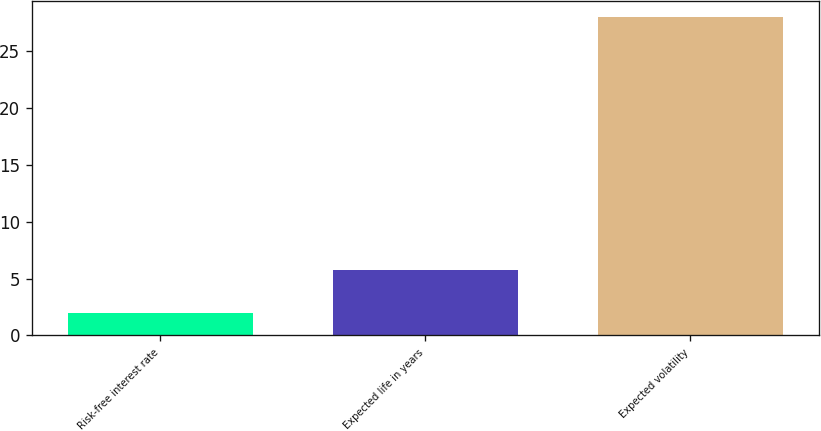Convert chart to OTSL. <chart><loc_0><loc_0><loc_500><loc_500><bar_chart><fcel>Risk-free interest rate<fcel>Expected life in years<fcel>Expected volatility<nl><fcel>2<fcel>5.8<fcel>28<nl></chart> 